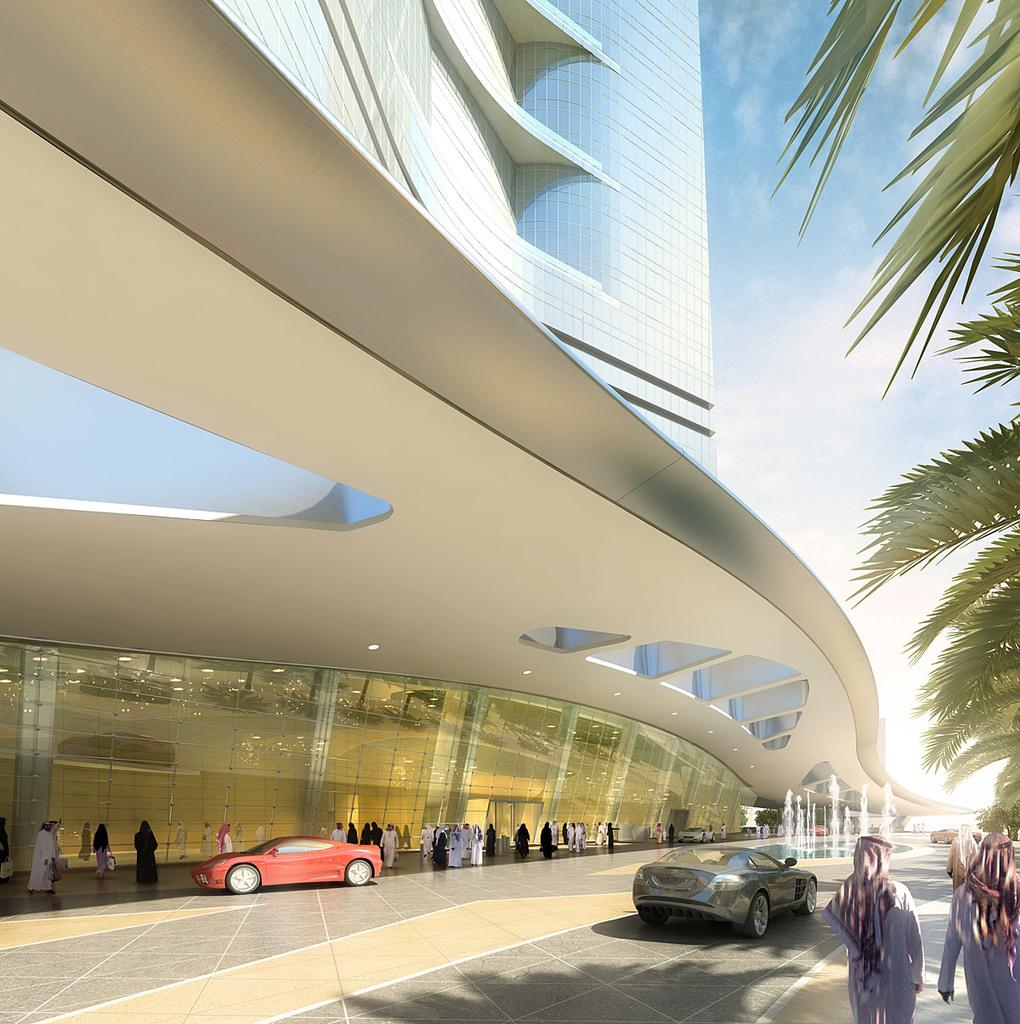Who or what can be seen in the image? There are people in the image. What else is visible on the ground in the image? There are cars on the road in the image. What can be seen in the distance in the image? There is a building, trees, and sculptures in the background of the image. What is visible in the sky at the top of the image? There are clouds visible in the sky at the top of the image. What type of jeans are the people wearing in the image? There is no information about the type of jeans the people are wearing in the image. 